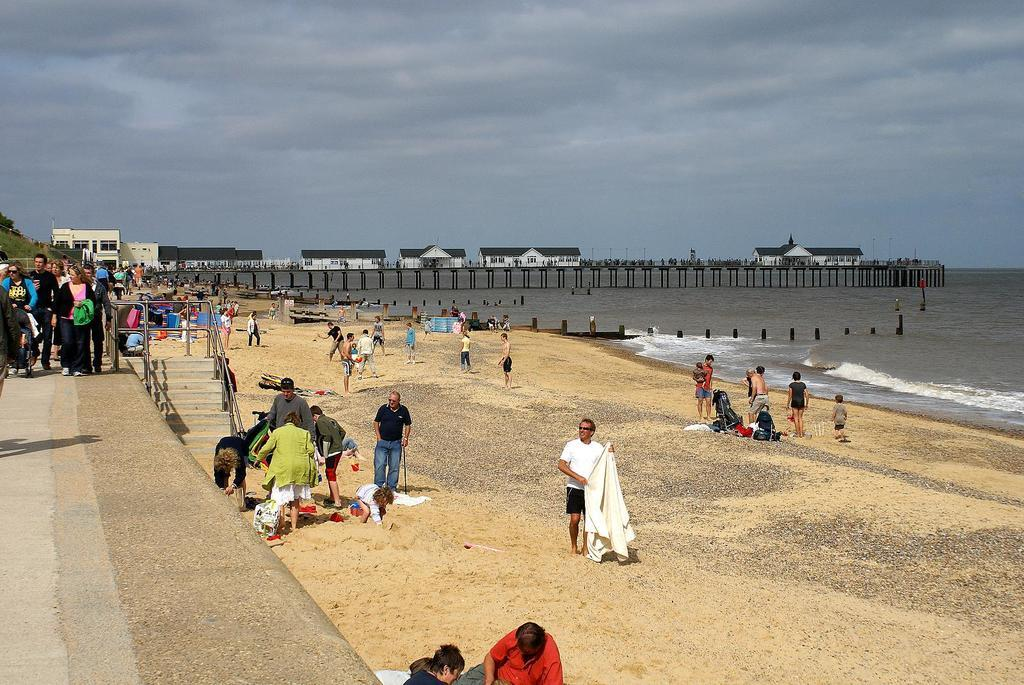What type of location is shown in the image? The image depicts a beach. Are there any people at the beach? Yes, there are people present at the beach. What are the people holding? The people are holding things, but the specific items are not mentioned in the facts. What is near the beach? There is a bridge near the beach. What can be seen on the bridge? There are houses on the bridge. What type of pie is being served at the beach in the image? There is no pie present in the image; it depicts a beach with people holding things and a bridge with houses. 